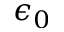<formula> <loc_0><loc_0><loc_500><loc_500>\epsilon _ { 0 }</formula> 